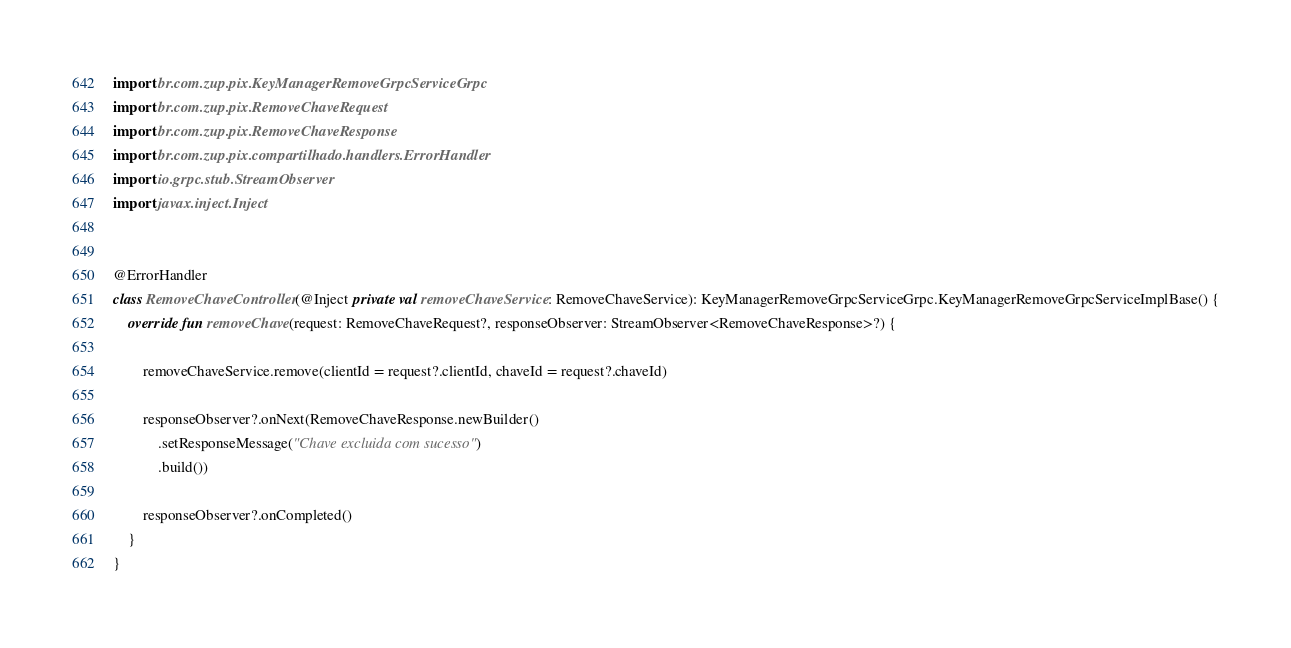<code> <loc_0><loc_0><loc_500><loc_500><_Kotlin_>import br.com.zup.pix.KeyManagerRemoveGrpcServiceGrpc
import br.com.zup.pix.RemoveChaveRequest
import br.com.zup.pix.RemoveChaveResponse
import br.com.zup.pix.compartilhado.handlers.ErrorHandler
import io.grpc.stub.StreamObserver
import javax.inject.Inject


@ErrorHandler
class RemoveChaveController(@Inject private val removeChaveService: RemoveChaveService): KeyManagerRemoveGrpcServiceGrpc.KeyManagerRemoveGrpcServiceImplBase() {
    override fun removeChave(request: RemoveChaveRequest?, responseObserver: StreamObserver<RemoveChaveResponse>?) {

        removeChaveService.remove(clientId = request?.clientId, chaveId = request?.chaveId)

        responseObserver?.onNext(RemoveChaveResponse.newBuilder()
            .setResponseMessage("Chave excluida com sucesso")
            .build())

        responseObserver?.onCompleted()
    }
}</code> 